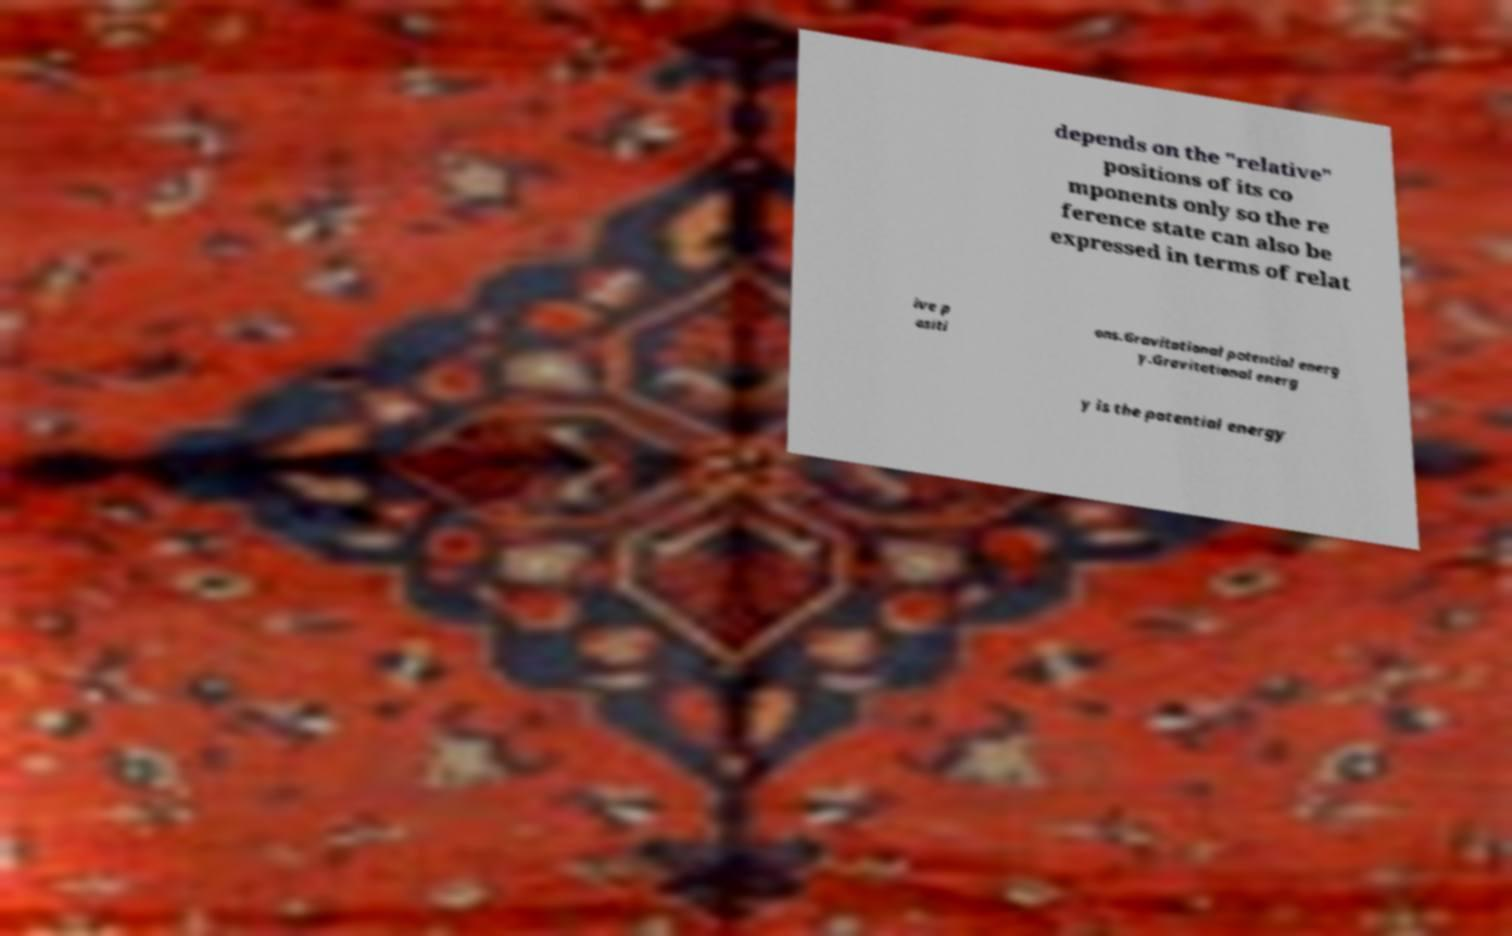Could you assist in decoding the text presented in this image and type it out clearly? depends on the "relative" positions of its co mponents only so the re ference state can also be expressed in terms of relat ive p ositi ons.Gravitational potential energ y.Gravitational energ y is the potential energy 